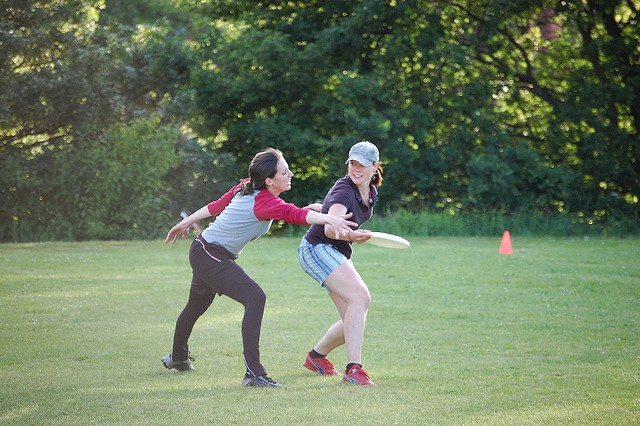Describe the objects in this image and their specific colors. I can see people in darkgreen, gray, darkgray, lavender, and brown tones, people in darkgreen, lavender, darkgray, lightgray, and pink tones, and frisbee in darkgreen, white, beige, and darkgray tones in this image. 